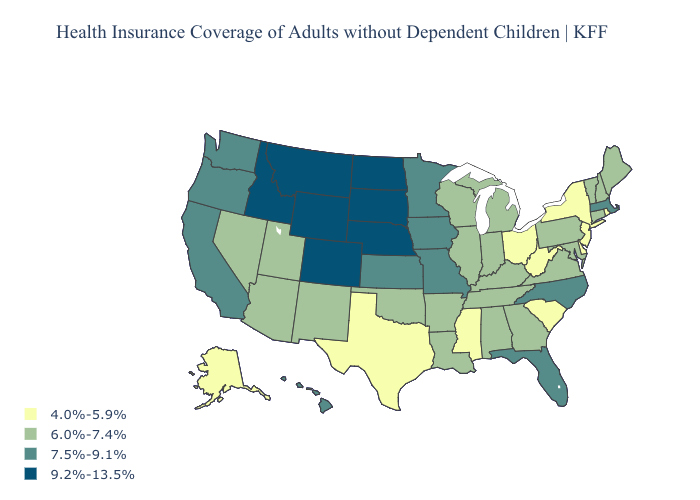What is the value of Minnesota?
Give a very brief answer. 7.5%-9.1%. What is the value of North Dakota?
Be succinct. 9.2%-13.5%. Does Michigan have a lower value than Utah?
Concise answer only. No. How many symbols are there in the legend?
Answer briefly. 4. What is the lowest value in the USA?
Answer briefly. 4.0%-5.9%. Among the states that border Louisiana , does Arkansas have the highest value?
Be succinct. Yes. Name the states that have a value in the range 7.5%-9.1%?
Answer briefly. California, Florida, Hawaii, Iowa, Kansas, Massachusetts, Minnesota, Missouri, North Carolina, Oregon, Washington. Name the states that have a value in the range 4.0%-5.9%?
Short answer required. Alaska, Delaware, Mississippi, New Jersey, New York, Ohio, Rhode Island, South Carolina, Texas, West Virginia. Name the states that have a value in the range 6.0%-7.4%?
Write a very short answer. Alabama, Arizona, Arkansas, Connecticut, Georgia, Illinois, Indiana, Kentucky, Louisiana, Maine, Maryland, Michigan, Nevada, New Hampshire, New Mexico, Oklahoma, Pennsylvania, Tennessee, Utah, Vermont, Virginia, Wisconsin. Name the states that have a value in the range 6.0%-7.4%?
Quick response, please. Alabama, Arizona, Arkansas, Connecticut, Georgia, Illinois, Indiana, Kentucky, Louisiana, Maine, Maryland, Michigan, Nevada, New Hampshire, New Mexico, Oklahoma, Pennsylvania, Tennessee, Utah, Vermont, Virginia, Wisconsin. Does Massachusetts have a higher value than Kansas?
Keep it brief. No. What is the value of Utah?
Quick response, please. 6.0%-7.4%. How many symbols are there in the legend?
Write a very short answer. 4. Among the states that border Missouri , does Nebraska have the lowest value?
Give a very brief answer. No. What is the value of Pennsylvania?
Be succinct. 6.0%-7.4%. 